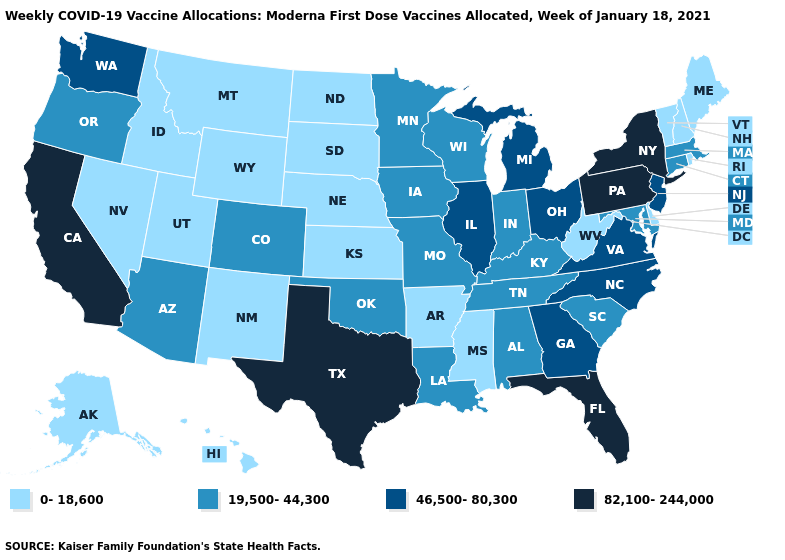Among the states that border Delaware , does Maryland have the highest value?
Keep it brief. No. What is the lowest value in states that border Idaho?
Short answer required. 0-18,600. What is the value of Arizona?
Be succinct. 19,500-44,300. Which states have the highest value in the USA?
Be succinct. California, Florida, New York, Pennsylvania, Texas. Which states have the lowest value in the West?
Be succinct. Alaska, Hawaii, Idaho, Montana, Nevada, New Mexico, Utah, Wyoming. Which states have the lowest value in the Northeast?
Answer briefly. Maine, New Hampshire, Rhode Island, Vermont. Among the states that border Montana , which have the lowest value?
Short answer required. Idaho, North Dakota, South Dakota, Wyoming. Which states have the lowest value in the USA?
Answer briefly. Alaska, Arkansas, Delaware, Hawaii, Idaho, Kansas, Maine, Mississippi, Montana, Nebraska, Nevada, New Hampshire, New Mexico, North Dakota, Rhode Island, South Dakota, Utah, Vermont, West Virginia, Wyoming. Among the states that border Florida , which have the lowest value?
Quick response, please. Alabama. What is the lowest value in the West?
Short answer required. 0-18,600. What is the value of West Virginia?
Keep it brief. 0-18,600. What is the value of Ohio?
Concise answer only. 46,500-80,300. Is the legend a continuous bar?
Write a very short answer. No. What is the lowest value in the Northeast?
Write a very short answer. 0-18,600. 